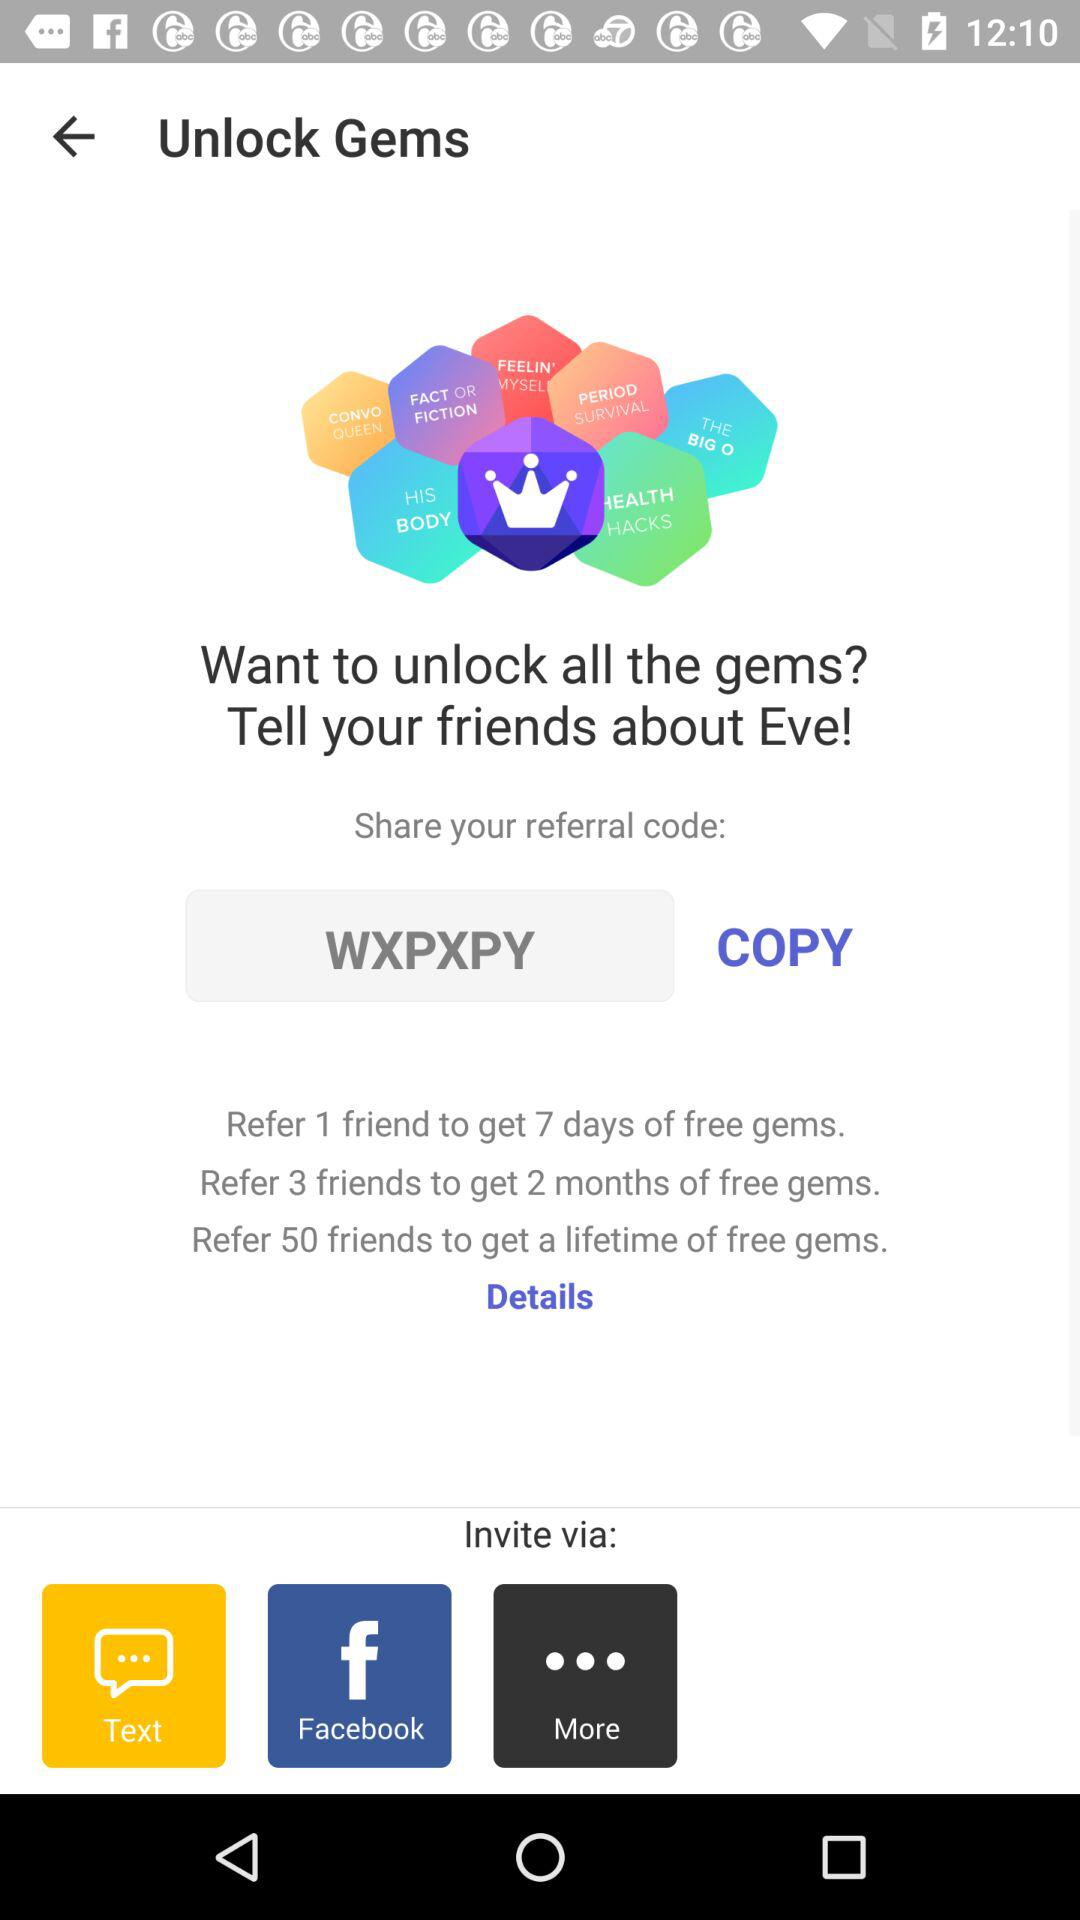What are the different options through which we can invite? The different options are "Text" and "Facebook". 